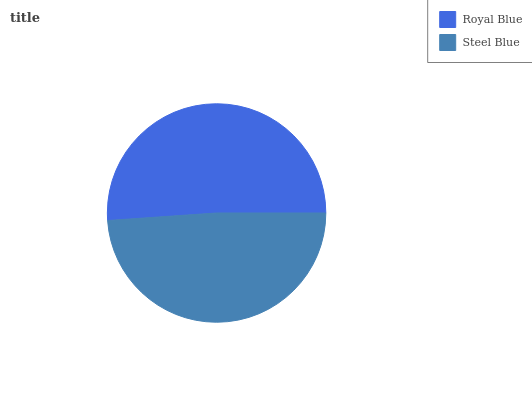Is Steel Blue the minimum?
Answer yes or no. Yes. Is Royal Blue the maximum?
Answer yes or no. Yes. Is Steel Blue the maximum?
Answer yes or no. No. Is Royal Blue greater than Steel Blue?
Answer yes or no. Yes. Is Steel Blue less than Royal Blue?
Answer yes or no. Yes. Is Steel Blue greater than Royal Blue?
Answer yes or no. No. Is Royal Blue less than Steel Blue?
Answer yes or no. No. Is Royal Blue the high median?
Answer yes or no. Yes. Is Steel Blue the low median?
Answer yes or no. Yes. Is Steel Blue the high median?
Answer yes or no. No. Is Royal Blue the low median?
Answer yes or no. No. 